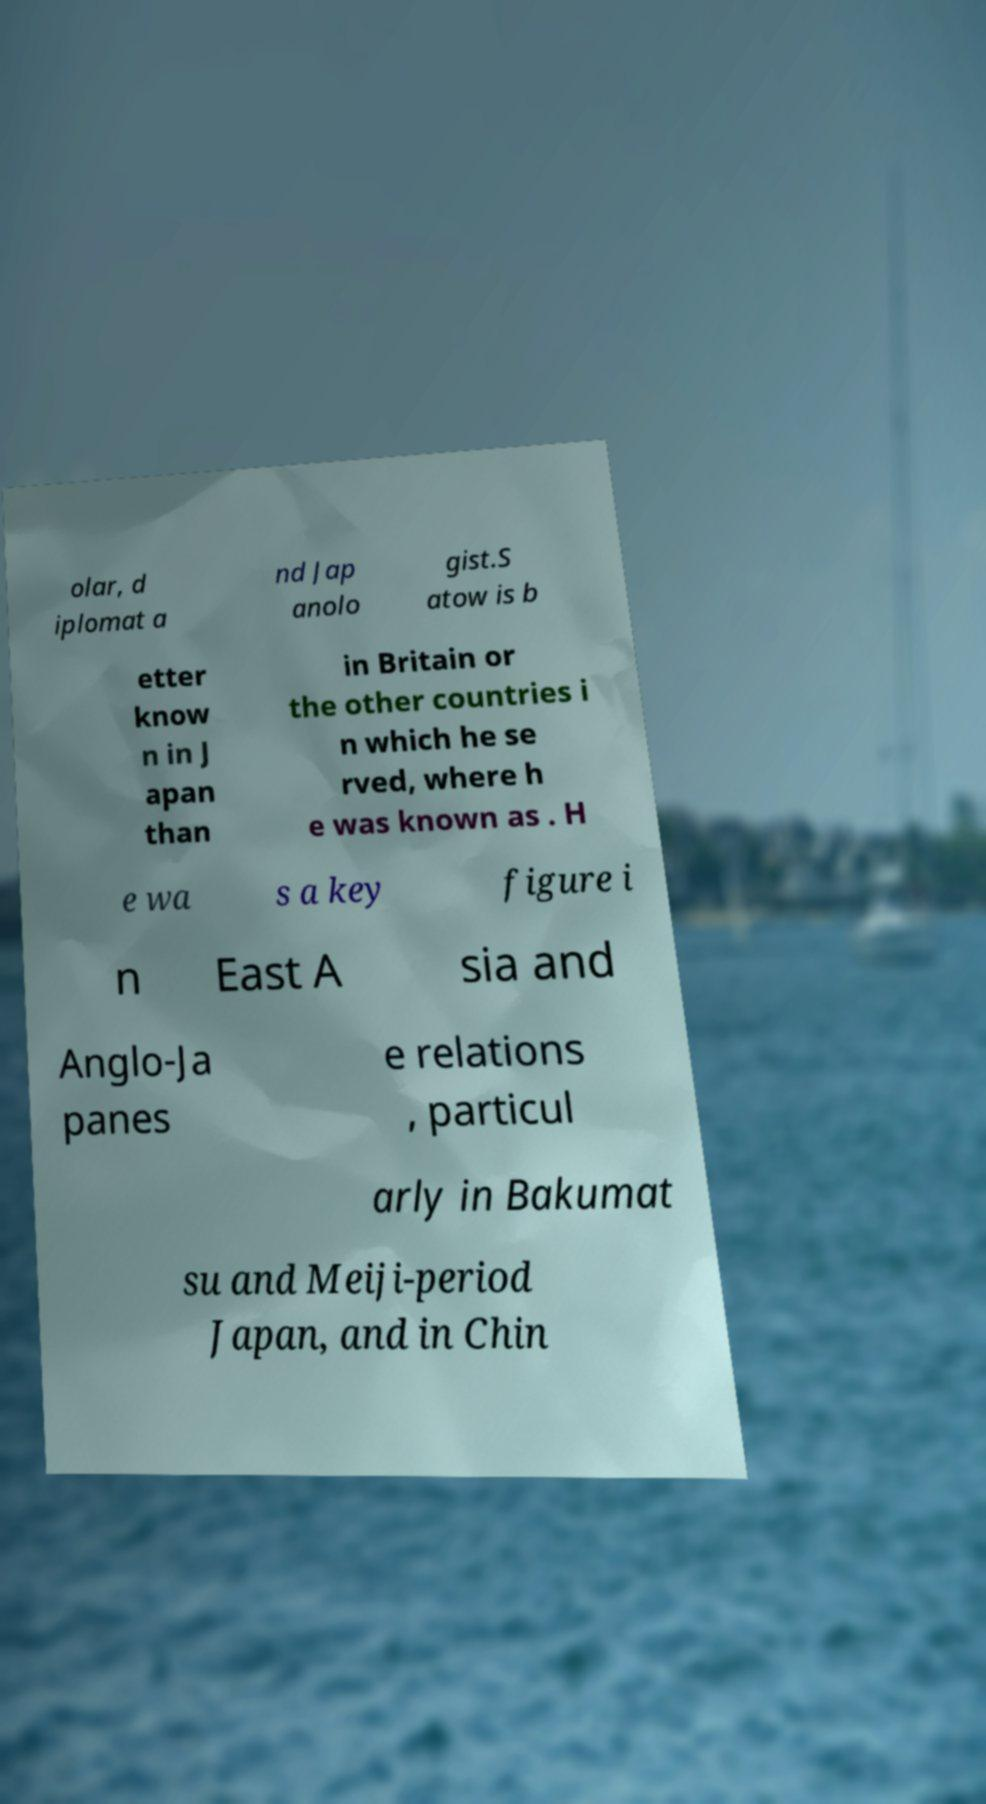Can you accurately transcribe the text from the provided image for me? olar, d iplomat a nd Jap anolo gist.S atow is b etter know n in J apan than in Britain or the other countries i n which he se rved, where h e was known as . H e wa s a key figure i n East A sia and Anglo-Ja panes e relations , particul arly in Bakumat su and Meiji-period Japan, and in Chin 